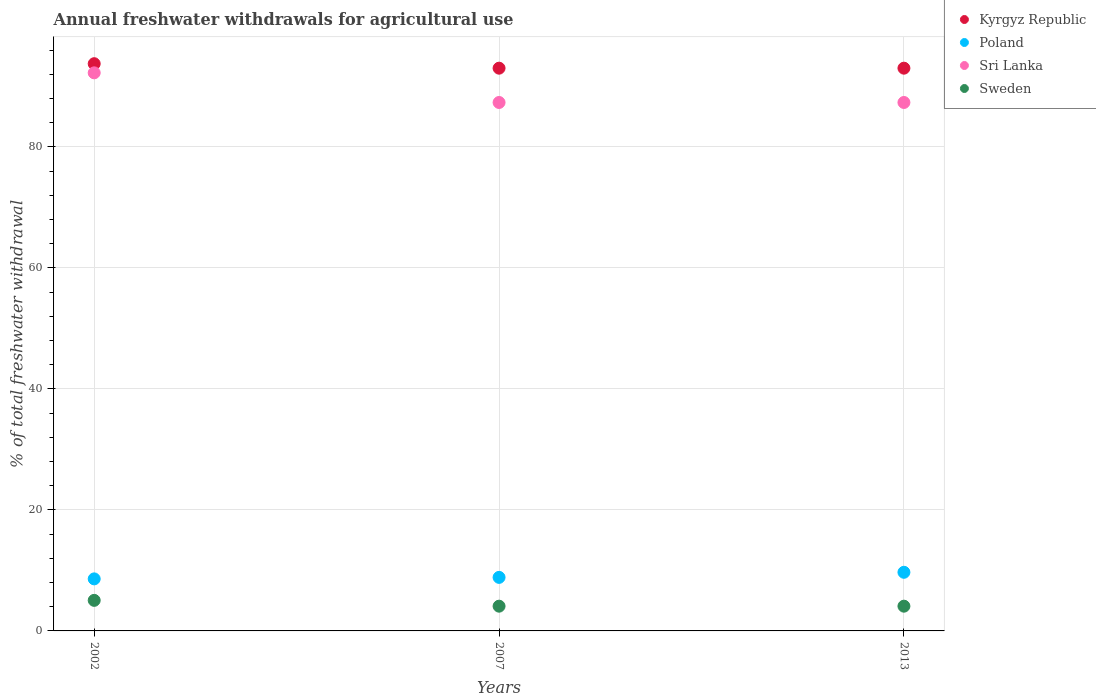How many different coloured dotlines are there?
Your answer should be compact. 4. What is the total annual withdrawals from freshwater in Sweden in 2013?
Make the answer very short. 4.09. Across all years, what is the maximum total annual withdrawals from freshwater in Poland?
Offer a very short reply. 9.69. Across all years, what is the minimum total annual withdrawals from freshwater in Kyrgyz Republic?
Provide a succinct answer. 93.01. In which year was the total annual withdrawals from freshwater in Sri Lanka minimum?
Your response must be concise. 2007. What is the total total annual withdrawals from freshwater in Sri Lanka in the graph?
Your response must be concise. 266.92. What is the difference between the total annual withdrawals from freshwater in Kyrgyz Republic in 2002 and that in 2013?
Your response must be concise. 0.74. What is the difference between the total annual withdrawals from freshwater in Poland in 2013 and the total annual withdrawals from freshwater in Sri Lanka in 2007?
Your answer should be very brief. -77.65. What is the average total annual withdrawals from freshwater in Sweden per year?
Keep it short and to the point. 4.41. In the year 2007, what is the difference between the total annual withdrawals from freshwater in Sri Lanka and total annual withdrawals from freshwater in Kyrgyz Republic?
Provide a succinct answer. -5.67. In how many years, is the total annual withdrawals from freshwater in Sri Lanka greater than 44 %?
Provide a short and direct response. 3. What is the ratio of the total annual withdrawals from freshwater in Kyrgyz Republic in 2002 to that in 2007?
Provide a succinct answer. 1.01. Is the total annual withdrawals from freshwater in Poland in 2007 less than that in 2013?
Offer a very short reply. Yes. What is the difference between the highest and the second highest total annual withdrawals from freshwater in Kyrgyz Republic?
Your answer should be very brief. 0.74. What is the difference between the highest and the lowest total annual withdrawals from freshwater in Sri Lanka?
Provide a succinct answer. 4.9. Is the sum of the total annual withdrawals from freshwater in Sweden in 2002 and 2007 greater than the maximum total annual withdrawals from freshwater in Poland across all years?
Make the answer very short. No. Is it the case that in every year, the sum of the total annual withdrawals from freshwater in Poland and total annual withdrawals from freshwater in Sweden  is greater than the total annual withdrawals from freshwater in Sri Lanka?
Your answer should be compact. No. Is the total annual withdrawals from freshwater in Sri Lanka strictly greater than the total annual withdrawals from freshwater in Poland over the years?
Give a very brief answer. Yes. How many dotlines are there?
Your response must be concise. 4. What is the difference between two consecutive major ticks on the Y-axis?
Keep it short and to the point. 20. Are the values on the major ticks of Y-axis written in scientific E-notation?
Give a very brief answer. No. Does the graph contain any zero values?
Make the answer very short. No. How many legend labels are there?
Offer a very short reply. 4. What is the title of the graph?
Your answer should be very brief. Annual freshwater withdrawals for agricultural use. What is the label or title of the Y-axis?
Keep it short and to the point. % of total freshwater withdrawal. What is the % of total freshwater withdrawal of Kyrgyz Republic in 2002?
Provide a short and direct response. 93.75. What is the % of total freshwater withdrawal in Poland in 2002?
Offer a very short reply. 8.6. What is the % of total freshwater withdrawal in Sri Lanka in 2002?
Offer a terse response. 92.24. What is the % of total freshwater withdrawal of Sweden in 2002?
Give a very brief answer. 5.05. What is the % of total freshwater withdrawal in Kyrgyz Republic in 2007?
Give a very brief answer. 93.01. What is the % of total freshwater withdrawal of Poland in 2007?
Your response must be concise. 8.85. What is the % of total freshwater withdrawal in Sri Lanka in 2007?
Offer a terse response. 87.34. What is the % of total freshwater withdrawal of Sweden in 2007?
Your response must be concise. 4.09. What is the % of total freshwater withdrawal in Kyrgyz Republic in 2013?
Ensure brevity in your answer.  93.01. What is the % of total freshwater withdrawal in Poland in 2013?
Offer a very short reply. 9.69. What is the % of total freshwater withdrawal of Sri Lanka in 2013?
Provide a succinct answer. 87.34. What is the % of total freshwater withdrawal of Sweden in 2013?
Offer a very short reply. 4.09. Across all years, what is the maximum % of total freshwater withdrawal of Kyrgyz Republic?
Offer a terse response. 93.75. Across all years, what is the maximum % of total freshwater withdrawal in Poland?
Offer a terse response. 9.69. Across all years, what is the maximum % of total freshwater withdrawal of Sri Lanka?
Your answer should be compact. 92.24. Across all years, what is the maximum % of total freshwater withdrawal of Sweden?
Make the answer very short. 5.05. Across all years, what is the minimum % of total freshwater withdrawal of Kyrgyz Republic?
Provide a succinct answer. 93.01. Across all years, what is the minimum % of total freshwater withdrawal of Poland?
Keep it short and to the point. 8.6. Across all years, what is the minimum % of total freshwater withdrawal of Sri Lanka?
Offer a very short reply. 87.34. Across all years, what is the minimum % of total freshwater withdrawal of Sweden?
Your answer should be very brief. 4.09. What is the total % of total freshwater withdrawal of Kyrgyz Republic in the graph?
Your response must be concise. 279.77. What is the total % of total freshwater withdrawal of Poland in the graph?
Offer a terse response. 27.14. What is the total % of total freshwater withdrawal in Sri Lanka in the graph?
Your answer should be compact. 266.92. What is the total % of total freshwater withdrawal in Sweden in the graph?
Offer a terse response. 13.23. What is the difference between the % of total freshwater withdrawal in Kyrgyz Republic in 2002 and that in 2007?
Ensure brevity in your answer.  0.74. What is the difference between the % of total freshwater withdrawal in Poland in 2002 and that in 2007?
Ensure brevity in your answer.  -0.25. What is the difference between the % of total freshwater withdrawal in Kyrgyz Republic in 2002 and that in 2013?
Offer a very short reply. 0.74. What is the difference between the % of total freshwater withdrawal of Poland in 2002 and that in 2013?
Give a very brief answer. -1.09. What is the difference between the % of total freshwater withdrawal in Kyrgyz Republic in 2007 and that in 2013?
Make the answer very short. 0. What is the difference between the % of total freshwater withdrawal of Poland in 2007 and that in 2013?
Offer a very short reply. -0.84. What is the difference between the % of total freshwater withdrawal in Sweden in 2007 and that in 2013?
Your answer should be very brief. 0. What is the difference between the % of total freshwater withdrawal of Kyrgyz Republic in 2002 and the % of total freshwater withdrawal of Poland in 2007?
Provide a short and direct response. 84.9. What is the difference between the % of total freshwater withdrawal in Kyrgyz Republic in 2002 and the % of total freshwater withdrawal in Sri Lanka in 2007?
Keep it short and to the point. 6.41. What is the difference between the % of total freshwater withdrawal of Kyrgyz Republic in 2002 and the % of total freshwater withdrawal of Sweden in 2007?
Make the answer very short. 89.66. What is the difference between the % of total freshwater withdrawal of Poland in 2002 and the % of total freshwater withdrawal of Sri Lanka in 2007?
Provide a succinct answer. -78.74. What is the difference between the % of total freshwater withdrawal of Poland in 2002 and the % of total freshwater withdrawal of Sweden in 2007?
Keep it short and to the point. 4.51. What is the difference between the % of total freshwater withdrawal of Sri Lanka in 2002 and the % of total freshwater withdrawal of Sweden in 2007?
Make the answer very short. 88.15. What is the difference between the % of total freshwater withdrawal in Kyrgyz Republic in 2002 and the % of total freshwater withdrawal in Poland in 2013?
Your answer should be compact. 84.06. What is the difference between the % of total freshwater withdrawal of Kyrgyz Republic in 2002 and the % of total freshwater withdrawal of Sri Lanka in 2013?
Make the answer very short. 6.41. What is the difference between the % of total freshwater withdrawal in Kyrgyz Republic in 2002 and the % of total freshwater withdrawal in Sweden in 2013?
Provide a short and direct response. 89.66. What is the difference between the % of total freshwater withdrawal of Poland in 2002 and the % of total freshwater withdrawal of Sri Lanka in 2013?
Make the answer very short. -78.74. What is the difference between the % of total freshwater withdrawal in Poland in 2002 and the % of total freshwater withdrawal in Sweden in 2013?
Provide a succinct answer. 4.51. What is the difference between the % of total freshwater withdrawal of Sri Lanka in 2002 and the % of total freshwater withdrawal of Sweden in 2013?
Provide a succinct answer. 88.15. What is the difference between the % of total freshwater withdrawal in Kyrgyz Republic in 2007 and the % of total freshwater withdrawal in Poland in 2013?
Give a very brief answer. 83.32. What is the difference between the % of total freshwater withdrawal in Kyrgyz Republic in 2007 and the % of total freshwater withdrawal in Sri Lanka in 2013?
Keep it short and to the point. 5.67. What is the difference between the % of total freshwater withdrawal in Kyrgyz Republic in 2007 and the % of total freshwater withdrawal in Sweden in 2013?
Your response must be concise. 88.92. What is the difference between the % of total freshwater withdrawal in Poland in 2007 and the % of total freshwater withdrawal in Sri Lanka in 2013?
Ensure brevity in your answer.  -78.49. What is the difference between the % of total freshwater withdrawal of Poland in 2007 and the % of total freshwater withdrawal of Sweden in 2013?
Give a very brief answer. 4.76. What is the difference between the % of total freshwater withdrawal in Sri Lanka in 2007 and the % of total freshwater withdrawal in Sweden in 2013?
Your response must be concise. 83.25. What is the average % of total freshwater withdrawal of Kyrgyz Republic per year?
Offer a terse response. 93.26. What is the average % of total freshwater withdrawal of Poland per year?
Your response must be concise. 9.05. What is the average % of total freshwater withdrawal in Sri Lanka per year?
Give a very brief answer. 88.97. What is the average % of total freshwater withdrawal in Sweden per year?
Offer a terse response. 4.41. In the year 2002, what is the difference between the % of total freshwater withdrawal in Kyrgyz Republic and % of total freshwater withdrawal in Poland?
Offer a very short reply. 85.15. In the year 2002, what is the difference between the % of total freshwater withdrawal in Kyrgyz Republic and % of total freshwater withdrawal in Sri Lanka?
Provide a short and direct response. 1.51. In the year 2002, what is the difference between the % of total freshwater withdrawal of Kyrgyz Republic and % of total freshwater withdrawal of Sweden?
Offer a very short reply. 88.7. In the year 2002, what is the difference between the % of total freshwater withdrawal in Poland and % of total freshwater withdrawal in Sri Lanka?
Ensure brevity in your answer.  -83.64. In the year 2002, what is the difference between the % of total freshwater withdrawal in Poland and % of total freshwater withdrawal in Sweden?
Your response must be concise. 3.55. In the year 2002, what is the difference between the % of total freshwater withdrawal of Sri Lanka and % of total freshwater withdrawal of Sweden?
Your response must be concise. 87.19. In the year 2007, what is the difference between the % of total freshwater withdrawal in Kyrgyz Republic and % of total freshwater withdrawal in Poland?
Your answer should be very brief. 84.16. In the year 2007, what is the difference between the % of total freshwater withdrawal of Kyrgyz Republic and % of total freshwater withdrawal of Sri Lanka?
Offer a terse response. 5.67. In the year 2007, what is the difference between the % of total freshwater withdrawal of Kyrgyz Republic and % of total freshwater withdrawal of Sweden?
Make the answer very short. 88.92. In the year 2007, what is the difference between the % of total freshwater withdrawal in Poland and % of total freshwater withdrawal in Sri Lanka?
Offer a terse response. -78.49. In the year 2007, what is the difference between the % of total freshwater withdrawal of Poland and % of total freshwater withdrawal of Sweden?
Offer a very short reply. 4.76. In the year 2007, what is the difference between the % of total freshwater withdrawal in Sri Lanka and % of total freshwater withdrawal in Sweden?
Make the answer very short. 83.25. In the year 2013, what is the difference between the % of total freshwater withdrawal in Kyrgyz Republic and % of total freshwater withdrawal in Poland?
Ensure brevity in your answer.  83.32. In the year 2013, what is the difference between the % of total freshwater withdrawal in Kyrgyz Republic and % of total freshwater withdrawal in Sri Lanka?
Ensure brevity in your answer.  5.67. In the year 2013, what is the difference between the % of total freshwater withdrawal in Kyrgyz Republic and % of total freshwater withdrawal in Sweden?
Keep it short and to the point. 88.92. In the year 2013, what is the difference between the % of total freshwater withdrawal in Poland and % of total freshwater withdrawal in Sri Lanka?
Offer a very short reply. -77.65. In the year 2013, what is the difference between the % of total freshwater withdrawal of Poland and % of total freshwater withdrawal of Sweden?
Make the answer very short. 5.6. In the year 2013, what is the difference between the % of total freshwater withdrawal of Sri Lanka and % of total freshwater withdrawal of Sweden?
Offer a very short reply. 83.25. What is the ratio of the % of total freshwater withdrawal of Poland in 2002 to that in 2007?
Offer a terse response. 0.97. What is the ratio of the % of total freshwater withdrawal in Sri Lanka in 2002 to that in 2007?
Your answer should be very brief. 1.06. What is the ratio of the % of total freshwater withdrawal in Sweden in 2002 to that in 2007?
Ensure brevity in your answer.  1.24. What is the ratio of the % of total freshwater withdrawal in Kyrgyz Republic in 2002 to that in 2013?
Offer a terse response. 1.01. What is the ratio of the % of total freshwater withdrawal of Poland in 2002 to that in 2013?
Keep it short and to the point. 0.89. What is the ratio of the % of total freshwater withdrawal in Sri Lanka in 2002 to that in 2013?
Keep it short and to the point. 1.06. What is the ratio of the % of total freshwater withdrawal of Sweden in 2002 to that in 2013?
Offer a very short reply. 1.24. What is the ratio of the % of total freshwater withdrawal in Kyrgyz Republic in 2007 to that in 2013?
Offer a very short reply. 1. What is the ratio of the % of total freshwater withdrawal in Poland in 2007 to that in 2013?
Your answer should be compact. 0.91. What is the ratio of the % of total freshwater withdrawal of Sri Lanka in 2007 to that in 2013?
Provide a short and direct response. 1. What is the ratio of the % of total freshwater withdrawal in Sweden in 2007 to that in 2013?
Keep it short and to the point. 1. What is the difference between the highest and the second highest % of total freshwater withdrawal of Kyrgyz Republic?
Keep it short and to the point. 0.74. What is the difference between the highest and the second highest % of total freshwater withdrawal in Poland?
Provide a succinct answer. 0.84. What is the difference between the highest and the lowest % of total freshwater withdrawal of Kyrgyz Republic?
Your answer should be compact. 0.74. What is the difference between the highest and the lowest % of total freshwater withdrawal in Poland?
Make the answer very short. 1.09. What is the difference between the highest and the lowest % of total freshwater withdrawal of Sri Lanka?
Your answer should be compact. 4.9. 